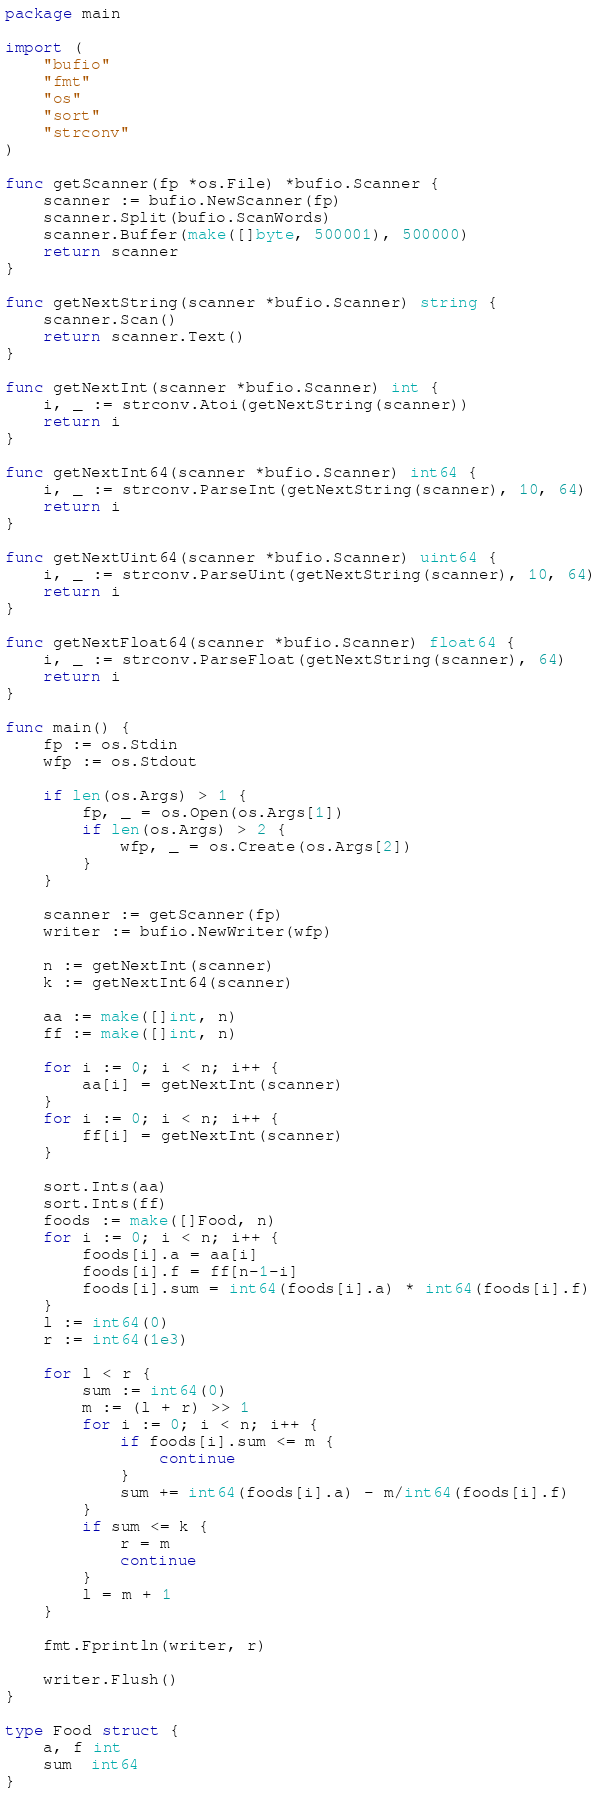Convert code to text. <code><loc_0><loc_0><loc_500><loc_500><_Go_>package main

import (
	"bufio"
	"fmt"
	"os"
	"sort"
	"strconv"
)

func getScanner(fp *os.File) *bufio.Scanner {
	scanner := bufio.NewScanner(fp)
	scanner.Split(bufio.ScanWords)
	scanner.Buffer(make([]byte, 500001), 500000)
	return scanner
}

func getNextString(scanner *bufio.Scanner) string {
	scanner.Scan()
	return scanner.Text()
}

func getNextInt(scanner *bufio.Scanner) int {
	i, _ := strconv.Atoi(getNextString(scanner))
	return i
}

func getNextInt64(scanner *bufio.Scanner) int64 {
	i, _ := strconv.ParseInt(getNextString(scanner), 10, 64)
	return i
}

func getNextUint64(scanner *bufio.Scanner) uint64 {
	i, _ := strconv.ParseUint(getNextString(scanner), 10, 64)
	return i
}

func getNextFloat64(scanner *bufio.Scanner) float64 {
	i, _ := strconv.ParseFloat(getNextString(scanner), 64)
	return i
}

func main() {
	fp := os.Stdin
	wfp := os.Stdout

	if len(os.Args) > 1 {
		fp, _ = os.Open(os.Args[1])
		if len(os.Args) > 2 {
			wfp, _ = os.Create(os.Args[2])
		}
	}

	scanner := getScanner(fp)
	writer := bufio.NewWriter(wfp)

	n := getNextInt(scanner)
	k := getNextInt64(scanner)

	aa := make([]int, n)
	ff := make([]int, n)

	for i := 0; i < n; i++ {
		aa[i] = getNextInt(scanner)
	}
	for i := 0; i < n; i++ {
		ff[i] = getNextInt(scanner)
	}

	sort.Ints(aa)
	sort.Ints(ff)
	foods := make([]Food, n)
	for i := 0; i < n; i++ {
		foods[i].a = aa[i]
		foods[i].f = ff[n-1-i]
		foods[i].sum = int64(foods[i].a) * int64(foods[i].f)
	}
	l := int64(0)
	r := int64(1e3)

	for l < r {
		sum := int64(0)
		m := (l + r) >> 1
		for i := 0; i < n; i++ {
			if foods[i].sum <= m {
				continue
			}
			sum += int64(foods[i].a) - m/int64(foods[i].f)
		}
		if sum <= k {
			r = m
			continue
		}
		l = m + 1
	}

	fmt.Fprintln(writer, r)

	writer.Flush()
}

type Food struct {
	a, f int
	sum  int64
}
</code> 